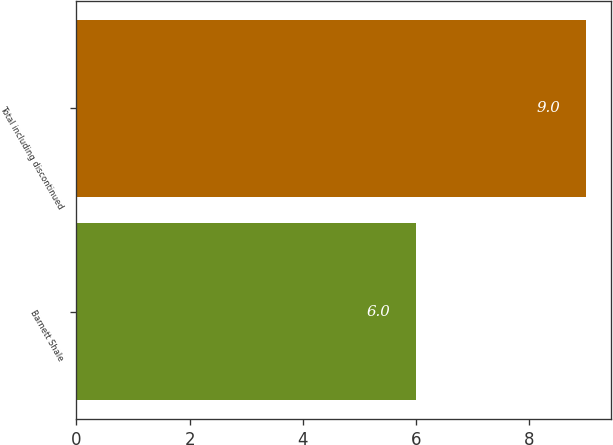<chart> <loc_0><loc_0><loc_500><loc_500><bar_chart><fcel>Barnett Shale<fcel>Total including discontinued<nl><fcel>6<fcel>9<nl></chart> 